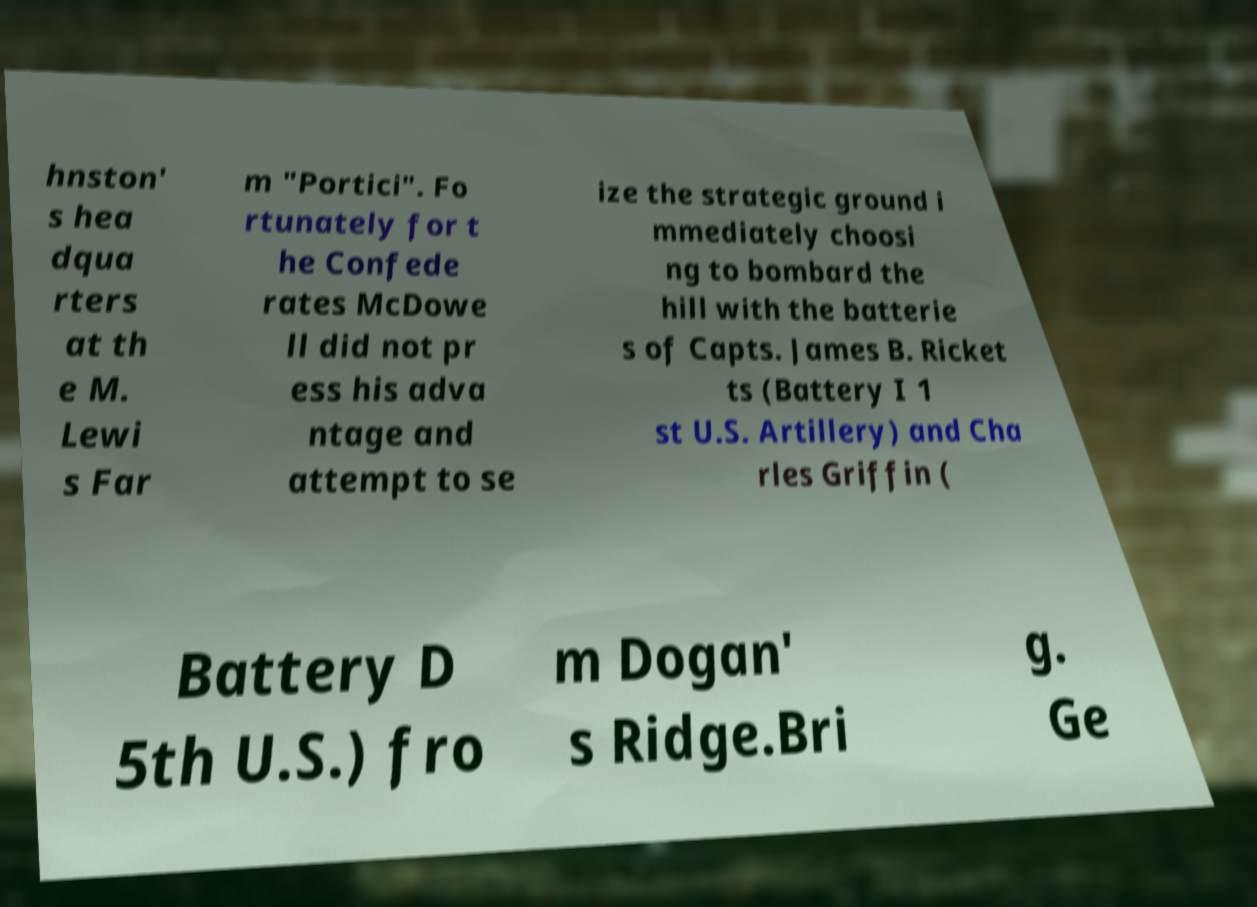I need the written content from this picture converted into text. Can you do that? hnston' s hea dqua rters at th e M. Lewi s Far m "Portici". Fo rtunately for t he Confede rates McDowe ll did not pr ess his adva ntage and attempt to se ize the strategic ground i mmediately choosi ng to bombard the hill with the batterie s of Capts. James B. Ricket ts (Battery I 1 st U.S. Artillery) and Cha rles Griffin ( Battery D 5th U.S.) fro m Dogan' s Ridge.Bri g. Ge 